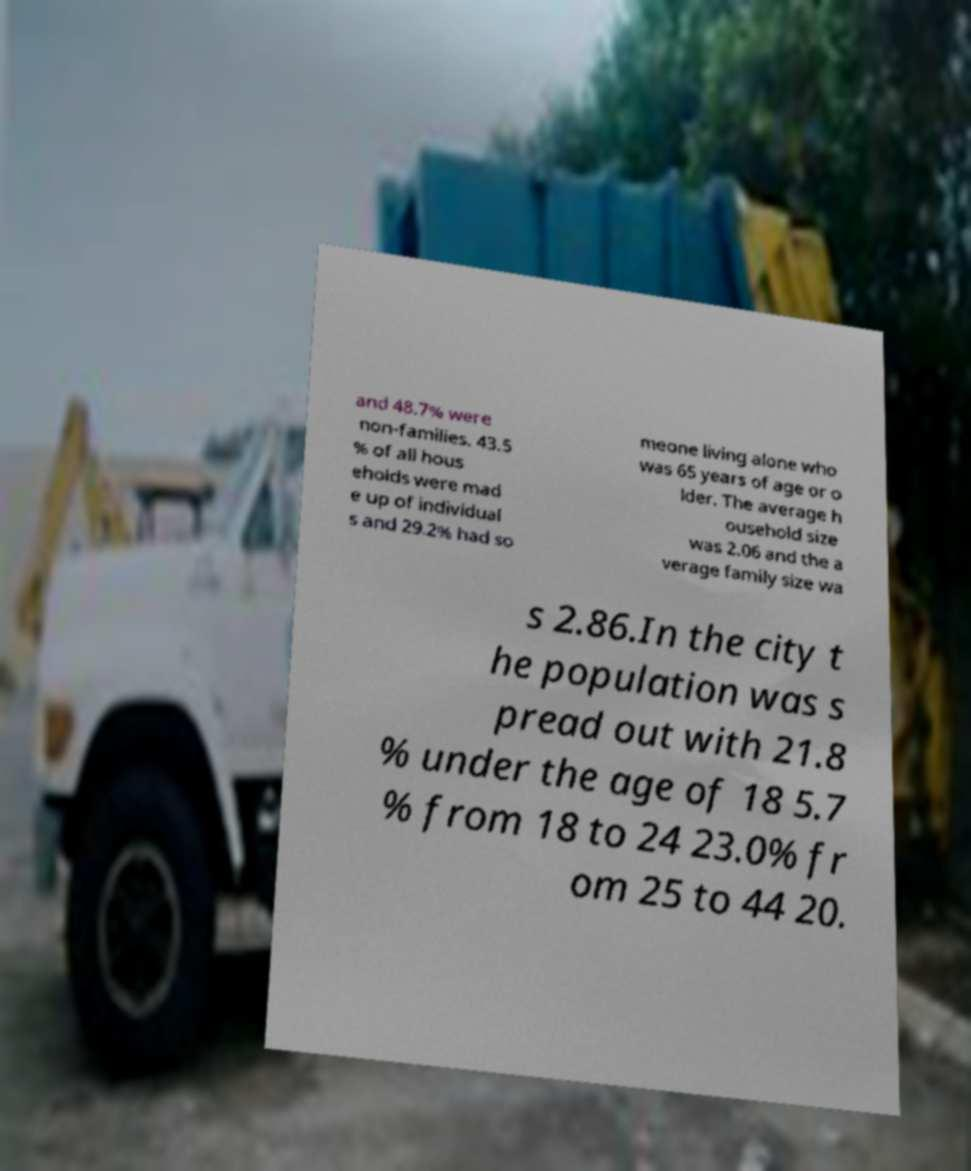What messages or text are displayed in this image? I need them in a readable, typed format. and 48.7% were non-families. 43.5 % of all hous eholds were mad e up of individual s and 29.2% had so meone living alone who was 65 years of age or o lder. The average h ousehold size was 2.06 and the a verage family size wa s 2.86.In the city t he population was s pread out with 21.8 % under the age of 18 5.7 % from 18 to 24 23.0% fr om 25 to 44 20. 